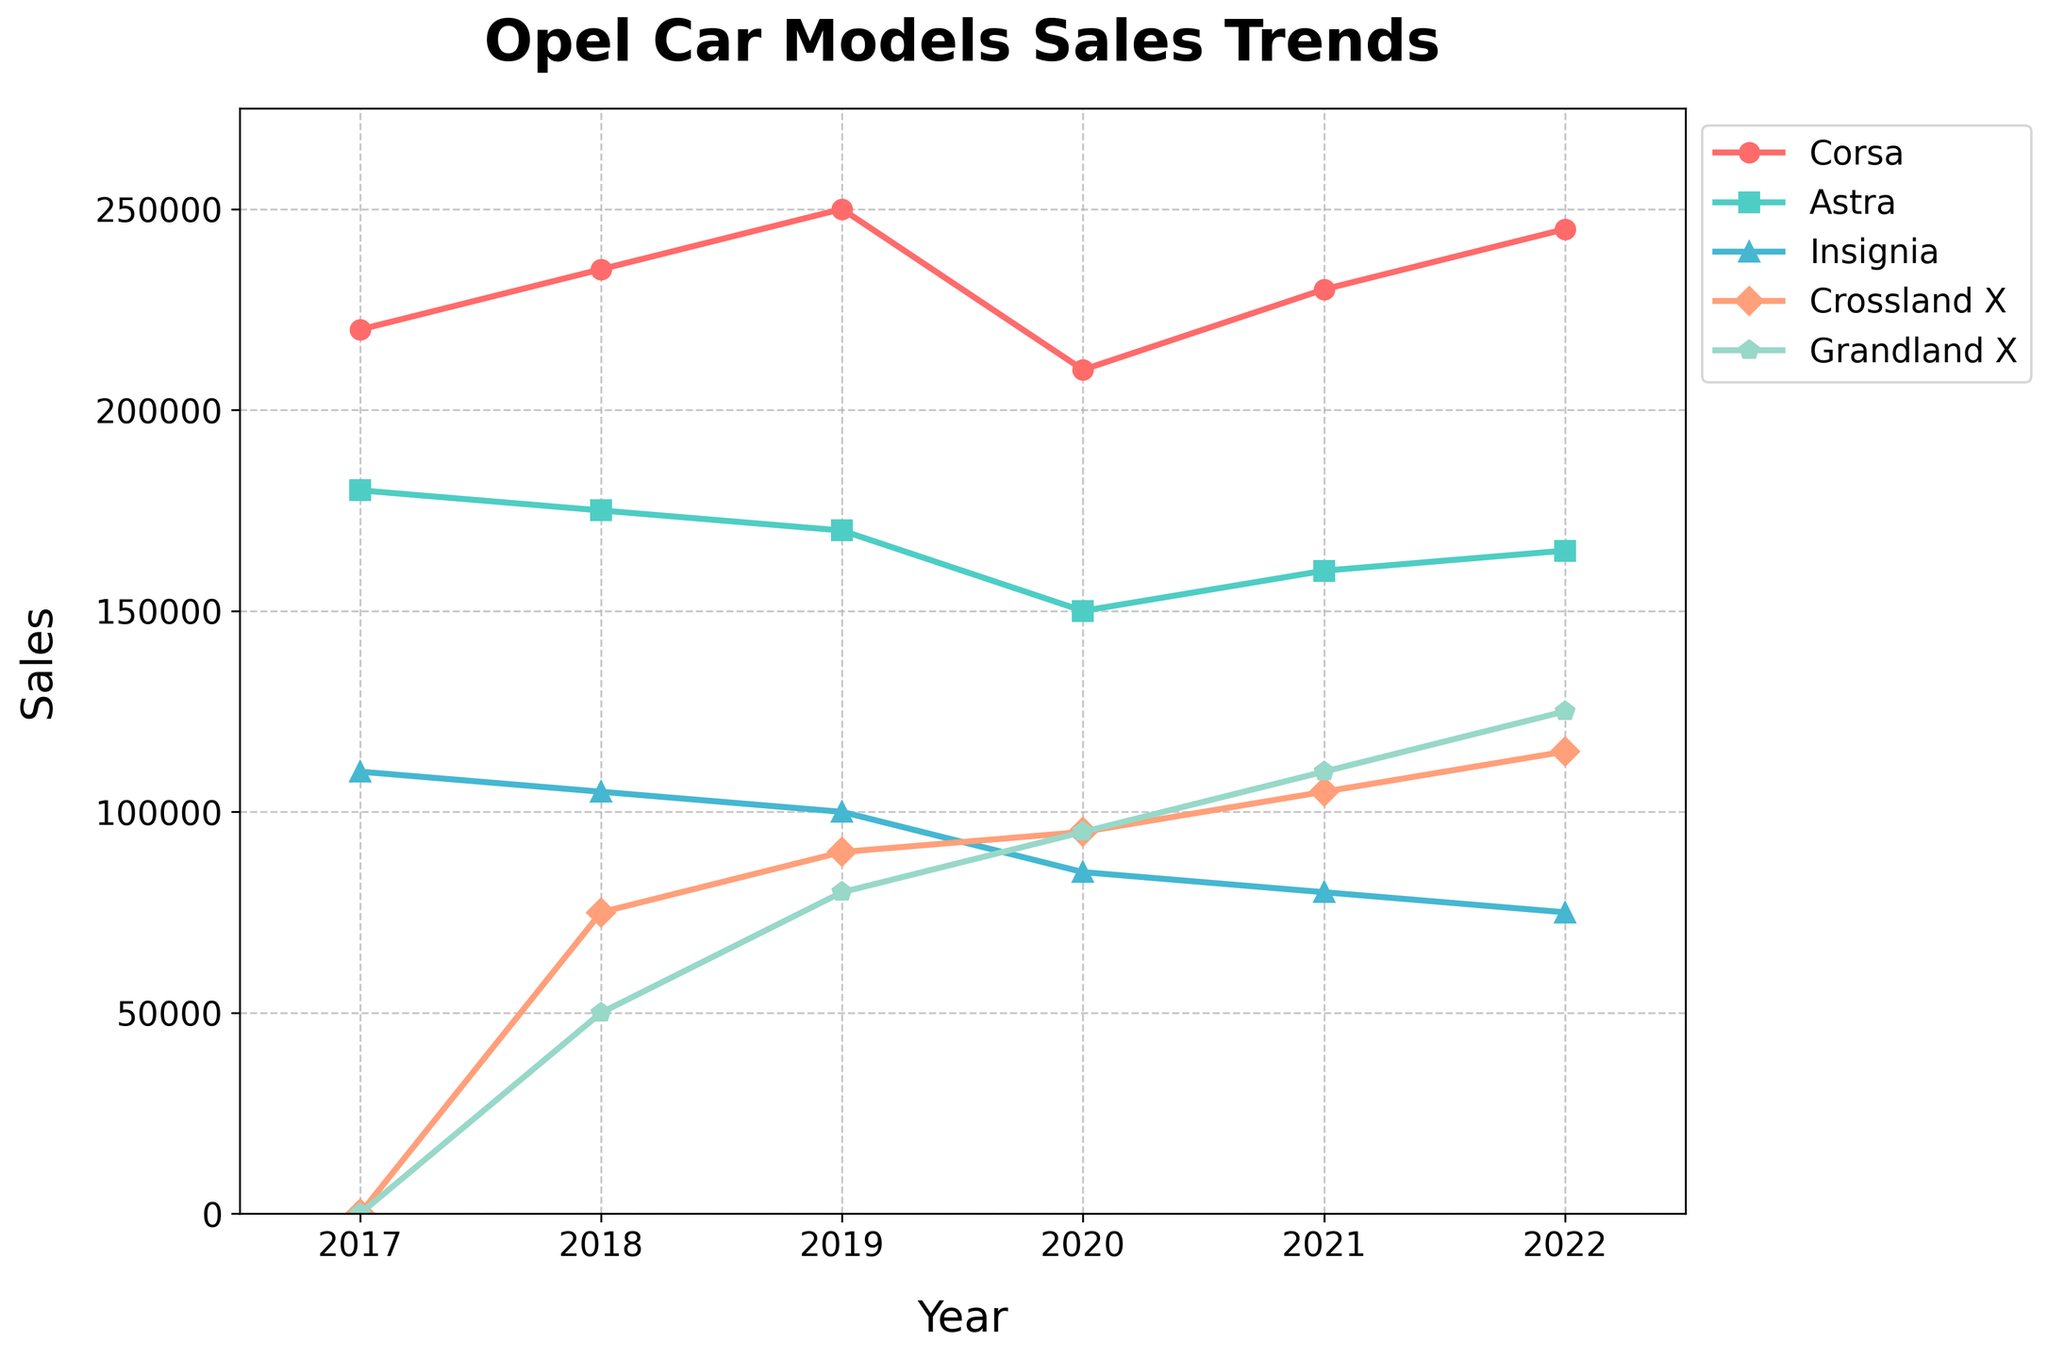Which Opel car model had the highest sales in 2022? To determine the highest sales, check the sales value for each model in 2022. Corsa had 245,000, Astra had 165,000, Insignia had 75,000, Crossland X had 115,000, and Grandland X had 125,000. Corsa's sales of 245,000 are the highest.
Answer: Corsa Between 2017 and 2022, which Opel model showed the most consistent sales trend? Consistency in sales means the least fluctuation over the years. The Corsa model had relatively stable sales fluctuating slightly between 220,000 and 250,000 units from 2017 to 2022. Other models had larger fluctuations or started sales later.
Answer: Corsa What is the total sales of Grandland X from 2018 to 2022? Add the sales figures for Grandland X from 2018 to 2022: 50,000 (2018) + 80,000 (2019) + 95,000 (2020) + 110,000 (2021) + 125,000 (2022) = 460,000.
Answer: 460,000 Which model had higher sales in 2021, Crossland X or Insignia? Compare the sales numbers: Crossland X had 105,000 and Insignia had 80,000. Crossland X had higher sales.
Answer: Crossland X Which model had the largest increase in sales from 2021 to 2022? Calculate the increase for each model by subtracting 2021 sales from 2022 sales. Corsa: 245,000 - 230,000 = 15,000, Astra: 165,000 - 160,000 = 5,000, Insignia: 75,000 - 80,000 = -5,000, Crossland X: 115,000 - 105,000 = 10,000, Grandland X: 125,000 - 110,000 = 15,000. Corsa and Grandland X had the largest increase of 15,000 units.
Answer: Corsa and Grandland X What was the average annual sales of the Insignia model from 2017 to 2022? Add the annual sales of Insignia and then divide by the number of years: (110,000 + 105,000 + 100,000 + 85,000 + 80,000 + 75,000) / 6 = 555,000 / 6 ≈ 92,500.
Answer: 92,500 Between Crossland X and Grandland X, which model's sales surpassed 100,000 units first? Check the sales data: Crossland X's sales surpassed 100,000 in 2021 with 105,000 units, while Grandland X also surpassed 100,000 in 2021 with 110,000 units. They both surpassed 100,000 units in the same year, 2021.
Answer: Both in 2021 From 2017 to 2022, which year did Astra have the lowest sales? Look at Astra's sales figures: 180,000 (2017), 175,000 (2018), 170,000 (2019), 150,000 (2020), 160,000 (2021), 165,000 (2022). The lowest sales were in 2020, with 150,000 units.
Answer: 2020 